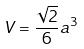<formula> <loc_0><loc_0><loc_500><loc_500>V = \frac { \sqrt { 2 } } { 6 } a ^ { 3 }</formula> 